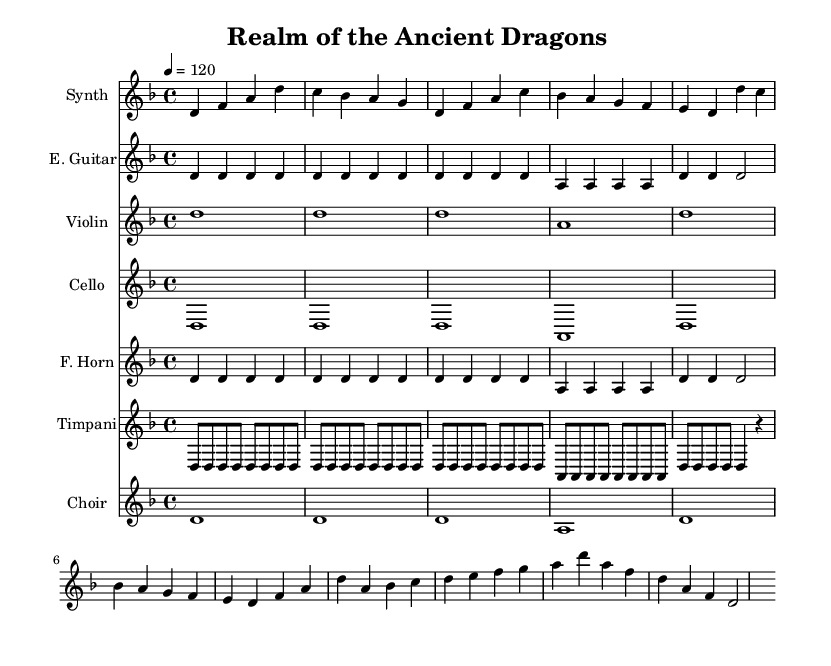What is the key signature of this music? The key signature is indicated at the beginning of the piece and consists of one flat, which means it is in D minor.
Answer: D minor What is the time signature of this music? The time signature is specified in the first measure, denoting that there are four beats per measure and each beat is a quarter note.
Answer: 4/4 What is the tempo marking of this piece? The tempo marking, found in the header section, is 120 beats per minute, indicating the speed at which the piece should be played.
Answer: 120 How many different instruments are featured in this score? By counting the distinct staff entries in the score, we find 6 unique instruments which are Synth, Electric Guitar, Violin, Cello, French Horn, Timpani, and Choir.
Answer: 7 Which instrument plays the melody in the first section? The melody can be identified by examining the highest notes or the most prominent parts in the first few measures, which is primarily played by the Synth.
Answer: Synth What is the overall mood conveyed by this electronic-orchestral fusion music? The mood can be determined by analyzing the instrumentation and harmonic choices, which combine electronic elements with orchestral richness, creating an epic and adventurous atmosphere typical of fantasy scores.
Answer: Epic What rhythmic pattern do the Timpani primarily use? The rhythmic pattern for the Timpani is based on a repeated pattern of eighth notes in the measures, which builds a sense of tension and urgency.
Answer: Eighth notes 